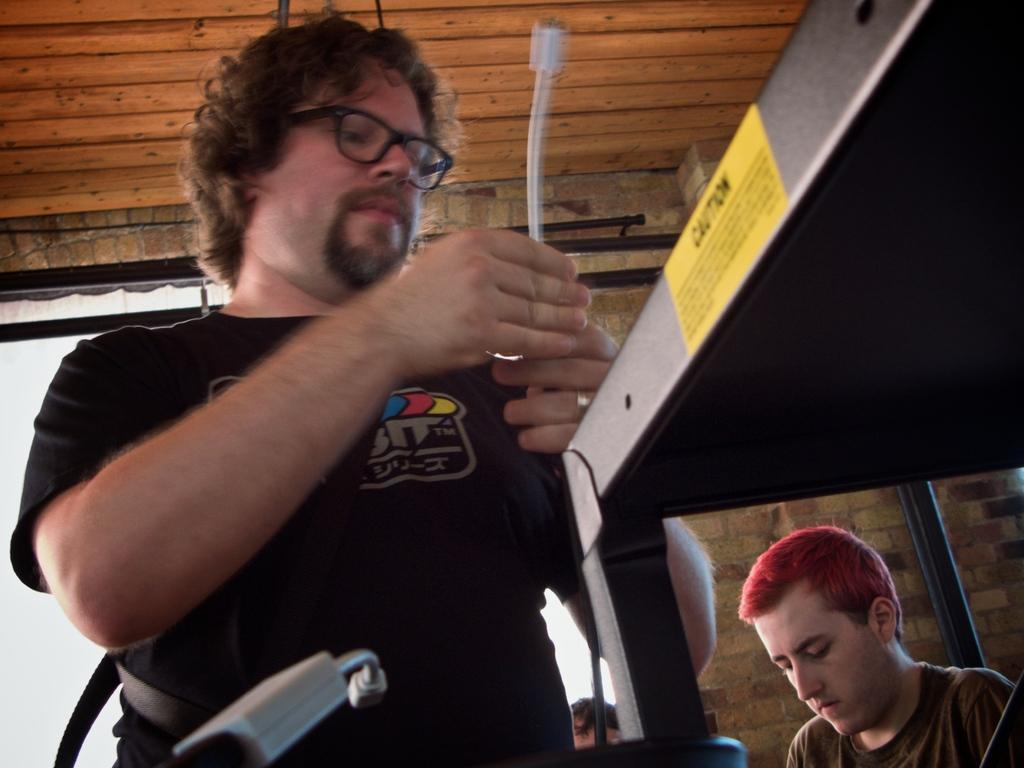How would you summarize this image in a sentence or two? In this image I can see two men and in the front I can see one of them is holding a white colour cable. I can also see both of them are wearing t shirts and one is wearing specs. In the front I can see one more cable, a black colour thing and on it I can see a yellow colour warning board. 